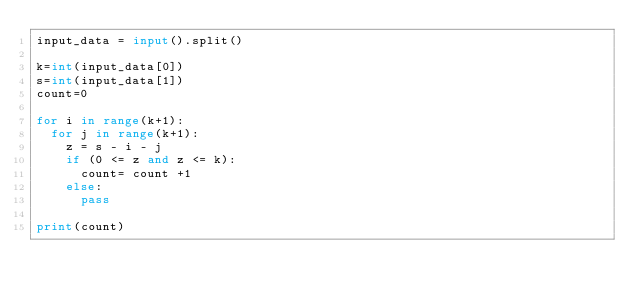<code> <loc_0><loc_0><loc_500><loc_500><_Python_>input_data = input().split()

k=int(input_data[0])
s=int(input_data[1])
count=0

for i in range(k+1):
  for j in range(k+1):
    z = s - i - j
    if (0 <= z and z <= k):
      count= count +1
    else:
      pass

print(count)</code> 